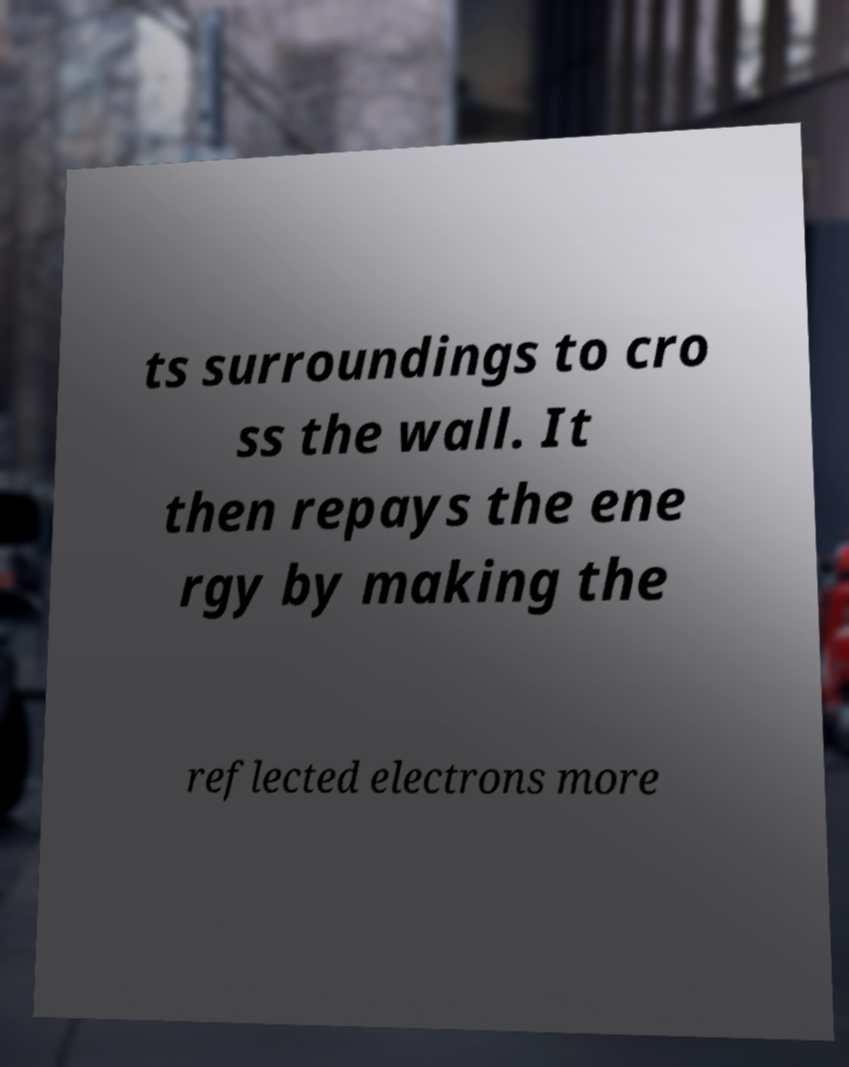Can you accurately transcribe the text from the provided image for me? ts surroundings to cro ss the wall. It then repays the ene rgy by making the reflected electrons more 